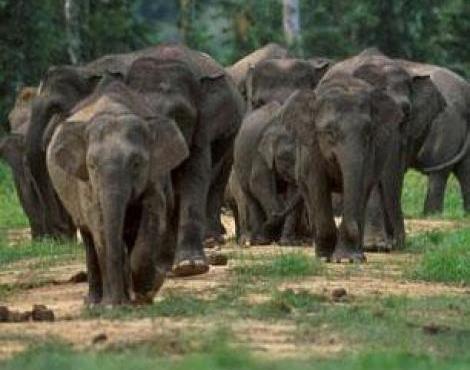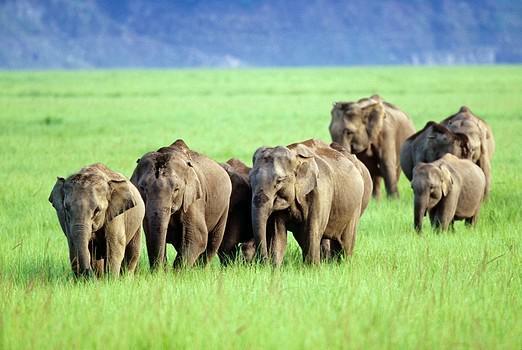The first image is the image on the left, the second image is the image on the right. Analyze the images presented: Is the assertion "An image shows just one elephant in the foreground." valid? Answer yes or no. No. 